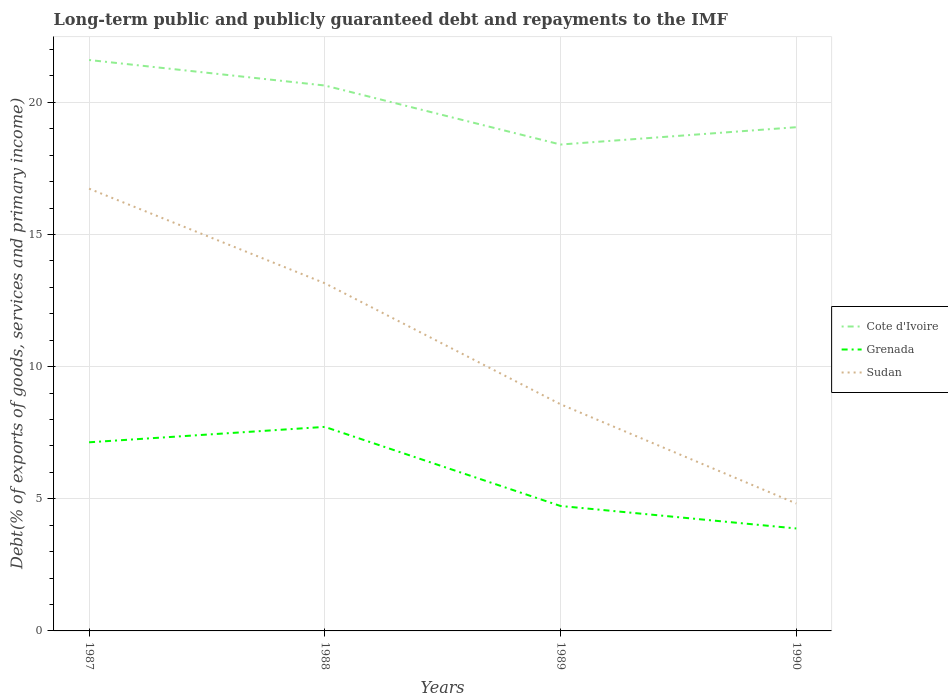Across all years, what is the maximum debt and repayments in Grenada?
Offer a very short reply. 3.88. In which year was the debt and repayments in Cote d'Ivoire maximum?
Make the answer very short. 1989. What is the total debt and repayments in Sudan in the graph?
Keep it short and to the point. 8.33. What is the difference between the highest and the second highest debt and repayments in Sudan?
Keep it short and to the point. 11.91. Is the debt and repayments in Cote d'Ivoire strictly greater than the debt and repayments in Sudan over the years?
Offer a terse response. No. How many years are there in the graph?
Provide a short and direct response. 4. Does the graph contain any zero values?
Make the answer very short. No. Where does the legend appear in the graph?
Offer a very short reply. Center right. How many legend labels are there?
Give a very brief answer. 3. What is the title of the graph?
Your answer should be compact. Long-term public and publicly guaranteed debt and repayments to the IMF. What is the label or title of the X-axis?
Ensure brevity in your answer.  Years. What is the label or title of the Y-axis?
Make the answer very short. Debt(% of exports of goods, services and primary income). What is the Debt(% of exports of goods, services and primary income) in Cote d'Ivoire in 1987?
Make the answer very short. 21.6. What is the Debt(% of exports of goods, services and primary income) of Grenada in 1987?
Offer a very short reply. 7.14. What is the Debt(% of exports of goods, services and primary income) in Sudan in 1987?
Make the answer very short. 16.74. What is the Debt(% of exports of goods, services and primary income) in Cote d'Ivoire in 1988?
Make the answer very short. 20.64. What is the Debt(% of exports of goods, services and primary income) of Grenada in 1988?
Your answer should be compact. 7.72. What is the Debt(% of exports of goods, services and primary income) of Sudan in 1988?
Ensure brevity in your answer.  13.16. What is the Debt(% of exports of goods, services and primary income) in Cote d'Ivoire in 1989?
Keep it short and to the point. 18.41. What is the Debt(% of exports of goods, services and primary income) in Grenada in 1989?
Provide a succinct answer. 4.73. What is the Debt(% of exports of goods, services and primary income) in Sudan in 1989?
Provide a succinct answer. 8.58. What is the Debt(% of exports of goods, services and primary income) in Cote d'Ivoire in 1990?
Keep it short and to the point. 19.06. What is the Debt(% of exports of goods, services and primary income) in Grenada in 1990?
Offer a very short reply. 3.88. What is the Debt(% of exports of goods, services and primary income) in Sudan in 1990?
Keep it short and to the point. 4.82. Across all years, what is the maximum Debt(% of exports of goods, services and primary income) in Cote d'Ivoire?
Your answer should be compact. 21.6. Across all years, what is the maximum Debt(% of exports of goods, services and primary income) in Grenada?
Offer a very short reply. 7.72. Across all years, what is the maximum Debt(% of exports of goods, services and primary income) of Sudan?
Your response must be concise. 16.74. Across all years, what is the minimum Debt(% of exports of goods, services and primary income) of Cote d'Ivoire?
Ensure brevity in your answer.  18.41. Across all years, what is the minimum Debt(% of exports of goods, services and primary income) of Grenada?
Offer a very short reply. 3.88. Across all years, what is the minimum Debt(% of exports of goods, services and primary income) of Sudan?
Your answer should be very brief. 4.82. What is the total Debt(% of exports of goods, services and primary income) in Cote d'Ivoire in the graph?
Offer a terse response. 79.71. What is the total Debt(% of exports of goods, services and primary income) of Grenada in the graph?
Offer a terse response. 23.46. What is the total Debt(% of exports of goods, services and primary income) of Sudan in the graph?
Keep it short and to the point. 43.29. What is the difference between the Debt(% of exports of goods, services and primary income) of Cote d'Ivoire in 1987 and that in 1988?
Offer a very short reply. 0.97. What is the difference between the Debt(% of exports of goods, services and primary income) of Grenada in 1987 and that in 1988?
Your answer should be compact. -0.58. What is the difference between the Debt(% of exports of goods, services and primary income) of Sudan in 1987 and that in 1988?
Your answer should be compact. 3.58. What is the difference between the Debt(% of exports of goods, services and primary income) of Cote d'Ivoire in 1987 and that in 1989?
Provide a succinct answer. 3.2. What is the difference between the Debt(% of exports of goods, services and primary income) in Grenada in 1987 and that in 1989?
Your answer should be very brief. 2.41. What is the difference between the Debt(% of exports of goods, services and primary income) in Sudan in 1987 and that in 1989?
Provide a succinct answer. 8.16. What is the difference between the Debt(% of exports of goods, services and primary income) of Cote d'Ivoire in 1987 and that in 1990?
Give a very brief answer. 2.54. What is the difference between the Debt(% of exports of goods, services and primary income) of Grenada in 1987 and that in 1990?
Provide a short and direct response. 3.26. What is the difference between the Debt(% of exports of goods, services and primary income) in Sudan in 1987 and that in 1990?
Your response must be concise. 11.91. What is the difference between the Debt(% of exports of goods, services and primary income) in Cote d'Ivoire in 1988 and that in 1989?
Your answer should be compact. 2.23. What is the difference between the Debt(% of exports of goods, services and primary income) in Grenada in 1988 and that in 1989?
Give a very brief answer. 2.99. What is the difference between the Debt(% of exports of goods, services and primary income) of Sudan in 1988 and that in 1989?
Ensure brevity in your answer.  4.58. What is the difference between the Debt(% of exports of goods, services and primary income) in Cote d'Ivoire in 1988 and that in 1990?
Your response must be concise. 1.58. What is the difference between the Debt(% of exports of goods, services and primary income) in Grenada in 1988 and that in 1990?
Your answer should be very brief. 3.84. What is the difference between the Debt(% of exports of goods, services and primary income) of Sudan in 1988 and that in 1990?
Your answer should be very brief. 8.33. What is the difference between the Debt(% of exports of goods, services and primary income) of Cote d'Ivoire in 1989 and that in 1990?
Provide a short and direct response. -0.66. What is the difference between the Debt(% of exports of goods, services and primary income) in Grenada in 1989 and that in 1990?
Provide a succinct answer. 0.85. What is the difference between the Debt(% of exports of goods, services and primary income) of Sudan in 1989 and that in 1990?
Ensure brevity in your answer.  3.75. What is the difference between the Debt(% of exports of goods, services and primary income) in Cote d'Ivoire in 1987 and the Debt(% of exports of goods, services and primary income) in Grenada in 1988?
Your response must be concise. 13.88. What is the difference between the Debt(% of exports of goods, services and primary income) of Cote d'Ivoire in 1987 and the Debt(% of exports of goods, services and primary income) of Sudan in 1988?
Ensure brevity in your answer.  8.45. What is the difference between the Debt(% of exports of goods, services and primary income) of Grenada in 1987 and the Debt(% of exports of goods, services and primary income) of Sudan in 1988?
Provide a short and direct response. -6.02. What is the difference between the Debt(% of exports of goods, services and primary income) of Cote d'Ivoire in 1987 and the Debt(% of exports of goods, services and primary income) of Grenada in 1989?
Provide a succinct answer. 16.88. What is the difference between the Debt(% of exports of goods, services and primary income) of Cote d'Ivoire in 1987 and the Debt(% of exports of goods, services and primary income) of Sudan in 1989?
Your answer should be very brief. 13.03. What is the difference between the Debt(% of exports of goods, services and primary income) of Grenada in 1987 and the Debt(% of exports of goods, services and primary income) of Sudan in 1989?
Offer a very short reply. -1.44. What is the difference between the Debt(% of exports of goods, services and primary income) in Cote d'Ivoire in 1987 and the Debt(% of exports of goods, services and primary income) in Grenada in 1990?
Your answer should be very brief. 17.73. What is the difference between the Debt(% of exports of goods, services and primary income) of Cote d'Ivoire in 1987 and the Debt(% of exports of goods, services and primary income) of Sudan in 1990?
Ensure brevity in your answer.  16.78. What is the difference between the Debt(% of exports of goods, services and primary income) of Grenada in 1987 and the Debt(% of exports of goods, services and primary income) of Sudan in 1990?
Offer a very short reply. 2.32. What is the difference between the Debt(% of exports of goods, services and primary income) of Cote d'Ivoire in 1988 and the Debt(% of exports of goods, services and primary income) of Grenada in 1989?
Your response must be concise. 15.91. What is the difference between the Debt(% of exports of goods, services and primary income) in Cote d'Ivoire in 1988 and the Debt(% of exports of goods, services and primary income) in Sudan in 1989?
Provide a succinct answer. 12.06. What is the difference between the Debt(% of exports of goods, services and primary income) of Grenada in 1988 and the Debt(% of exports of goods, services and primary income) of Sudan in 1989?
Give a very brief answer. -0.86. What is the difference between the Debt(% of exports of goods, services and primary income) in Cote d'Ivoire in 1988 and the Debt(% of exports of goods, services and primary income) in Grenada in 1990?
Your response must be concise. 16.76. What is the difference between the Debt(% of exports of goods, services and primary income) in Cote d'Ivoire in 1988 and the Debt(% of exports of goods, services and primary income) in Sudan in 1990?
Make the answer very short. 15.82. What is the difference between the Debt(% of exports of goods, services and primary income) of Grenada in 1988 and the Debt(% of exports of goods, services and primary income) of Sudan in 1990?
Provide a short and direct response. 2.9. What is the difference between the Debt(% of exports of goods, services and primary income) of Cote d'Ivoire in 1989 and the Debt(% of exports of goods, services and primary income) of Grenada in 1990?
Provide a succinct answer. 14.53. What is the difference between the Debt(% of exports of goods, services and primary income) of Cote d'Ivoire in 1989 and the Debt(% of exports of goods, services and primary income) of Sudan in 1990?
Keep it short and to the point. 13.58. What is the difference between the Debt(% of exports of goods, services and primary income) in Grenada in 1989 and the Debt(% of exports of goods, services and primary income) in Sudan in 1990?
Provide a short and direct response. -0.09. What is the average Debt(% of exports of goods, services and primary income) in Cote d'Ivoire per year?
Provide a short and direct response. 19.93. What is the average Debt(% of exports of goods, services and primary income) of Grenada per year?
Provide a succinct answer. 5.87. What is the average Debt(% of exports of goods, services and primary income) of Sudan per year?
Provide a short and direct response. 10.82. In the year 1987, what is the difference between the Debt(% of exports of goods, services and primary income) of Cote d'Ivoire and Debt(% of exports of goods, services and primary income) of Grenada?
Your answer should be very brief. 14.47. In the year 1987, what is the difference between the Debt(% of exports of goods, services and primary income) in Cote d'Ivoire and Debt(% of exports of goods, services and primary income) in Sudan?
Offer a very short reply. 4.87. In the year 1987, what is the difference between the Debt(% of exports of goods, services and primary income) in Grenada and Debt(% of exports of goods, services and primary income) in Sudan?
Provide a succinct answer. -9.6. In the year 1988, what is the difference between the Debt(% of exports of goods, services and primary income) of Cote d'Ivoire and Debt(% of exports of goods, services and primary income) of Grenada?
Ensure brevity in your answer.  12.92. In the year 1988, what is the difference between the Debt(% of exports of goods, services and primary income) of Cote d'Ivoire and Debt(% of exports of goods, services and primary income) of Sudan?
Your response must be concise. 7.48. In the year 1988, what is the difference between the Debt(% of exports of goods, services and primary income) of Grenada and Debt(% of exports of goods, services and primary income) of Sudan?
Give a very brief answer. -5.44. In the year 1989, what is the difference between the Debt(% of exports of goods, services and primary income) of Cote d'Ivoire and Debt(% of exports of goods, services and primary income) of Grenada?
Provide a succinct answer. 13.68. In the year 1989, what is the difference between the Debt(% of exports of goods, services and primary income) of Cote d'Ivoire and Debt(% of exports of goods, services and primary income) of Sudan?
Ensure brevity in your answer.  9.83. In the year 1989, what is the difference between the Debt(% of exports of goods, services and primary income) of Grenada and Debt(% of exports of goods, services and primary income) of Sudan?
Provide a succinct answer. -3.85. In the year 1990, what is the difference between the Debt(% of exports of goods, services and primary income) in Cote d'Ivoire and Debt(% of exports of goods, services and primary income) in Grenada?
Ensure brevity in your answer.  15.18. In the year 1990, what is the difference between the Debt(% of exports of goods, services and primary income) of Cote d'Ivoire and Debt(% of exports of goods, services and primary income) of Sudan?
Your answer should be very brief. 14.24. In the year 1990, what is the difference between the Debt(% of exports of goods, services and primary income) in Grenada and Debt(% of exports of goods, services and primary income) in Sudan?
Ensure brevity in your answer.  -0.94. What is the ratio of the Debt(% of exports of goods, services and primary income) of Cote d'Ivoire in 1987 to that in 1988?
Ensure brevity in your answer.  1.05. What is the ratio of the Debt(% of exports of goods, services and primary income) in Grenada in 1987 to that in 1988?
Offer a terse response. 0.92. What is the ratio of the Debt(% of exports of goods, services and primary income) of Sudan in 1987 to that in 1988?
Provide a short and direct response. 1.27. What is the ratio of the Debt(% of exports of goods, services and primary income) of Cote d'Ivoire in 1987 to that in 1989?
Provide a succinct answer. 1.17. What is the ratio of the Debt(% of exports of goods, services and primary income) of Grenada in 1987 to that in 1989?
Provide a short and direct response. 1.51. What is the ratio of the Debt(% of exports of goods, services and primary income) of Sudan in 1987 to that in 1989?
Make the answer very short. 1.95. What is the ratio of the Debt(% of exports of goods, services and primary income) in Cote d'Ivoire in 1987 to that in 1990?
Your answer should be compact. 1.13. What is the ratio of the Debt(% of exports of goods, services and primary income) of Grenada in 1987 to that in 1990?
Your answer should be compact. 1.84. What is the ratio of the Debt(% of exports of goods, services and primary income) of Sudan in 1987 to that in 1990?
Your answer should be compact. 3.47. What is the ratio of the Debt(% of exports of goods, services and primary income) of Cote d'Ivoire in 1988 to that in 1989?
Offer a terse response. 1.12. What is the ratio of the Debt(% of exports of goods, services and primary income) of Grenada in 1988 to that in 1989?
Offer a very short reply. 1.63. What is the ratio of the Debt(% of exports of goods, services and primary income) of Sudan in 1988 to that in 1989?
Keep it short and to the point. 1.53. What is the ratio of the Debt(% of exports of goods, services and primary income) in Cote d'Ivoire in 1988 to that in 1990?
Your answer should be compact. 1.08. What is the ratio of the Debt(% of exports of goods, services and primary income) in Grenada in 1988 to that in 1990?
Provide a succinct answer. 1.99. What is the ratio of the Debt(% of exports of goods, services and primary income) of Sudan in 1988 to that in 1990?
Keep it short and to the point. 2.73. What is the ratio of the Debt(% of exports of goods, services and primary income) in Cote d'Ivoire in 1989 to that in 1990?
Ensure brevity in your answer.  0.97. What is the ratio of the Debt(% of exports of goods, services and primary income) in Grenada in 1989 to that in 1990?
Ensure brevity in your answer.  1.22. What is the ratio of the Debt(% of exports of goods, services and primary income) of Sudan in 1989 to that in 1990?
Make the answer very short. 1.78. What is the difference between the highest and the second highest Debt(% of exports of goods, services and primary income) in Cote d'Ivoire?
Your response must be concise. 0.97. What is the difference between the highest and the second highest Debt(% of exports of goods, services and primary income) in Grenada?
Ensure brevity in your answer.  0.58. What is the difference between the highest and the second highest Debt(% of exports of goods, services and primary income) of Sudan?
Provide a succinct answer. 3.58. What is the difference between the highest and the lowest Debt(% of exports of goods, services and primary income) in Cote d'Ivoire?
Offer a terse response. 3.2. What is the difference between the highest and the lowest Debt(% of exports of goods, services and primary income) in Grenada?
Your answer should be very brief. 3.84. What is the difference between the highest and the lowest Debt(% of exports of goods, services and primary income) of Sudan?
Give a very brief answer. 11.91. 